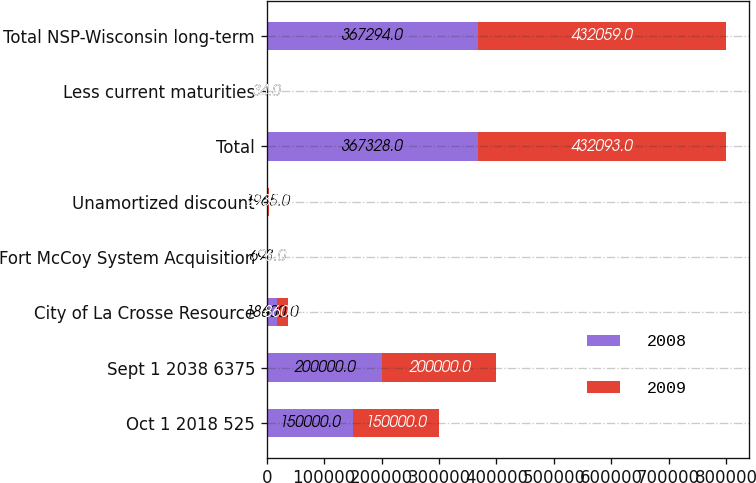<chart> <loc_0><loc_0><loc_500><loc_500><stacked_bar_chart><ecel><fcel>Oct 1 2018 525<fcel>Sept 1 2038 6375<fcel>City of La Crosse Resource<fcel>Fort McCoy System Acquisition<fcel>Unamortized discount<fcel>Total<fcel>Less current maturities<fcel>Total NSP-Wisconsin long-term<nl><fcel>2008<fcel>150000<fcel>200000<fcel>18600<fcel>693<fcel>1965<fcel>367328<fcel>34<fcel>367294<nl><fcel>2009<fcel>150000<fcel>200000<fcel>18600<fcel>726<fcel>2233<fcel>432093<fcel>34<fcel>432059<nl></chart> 